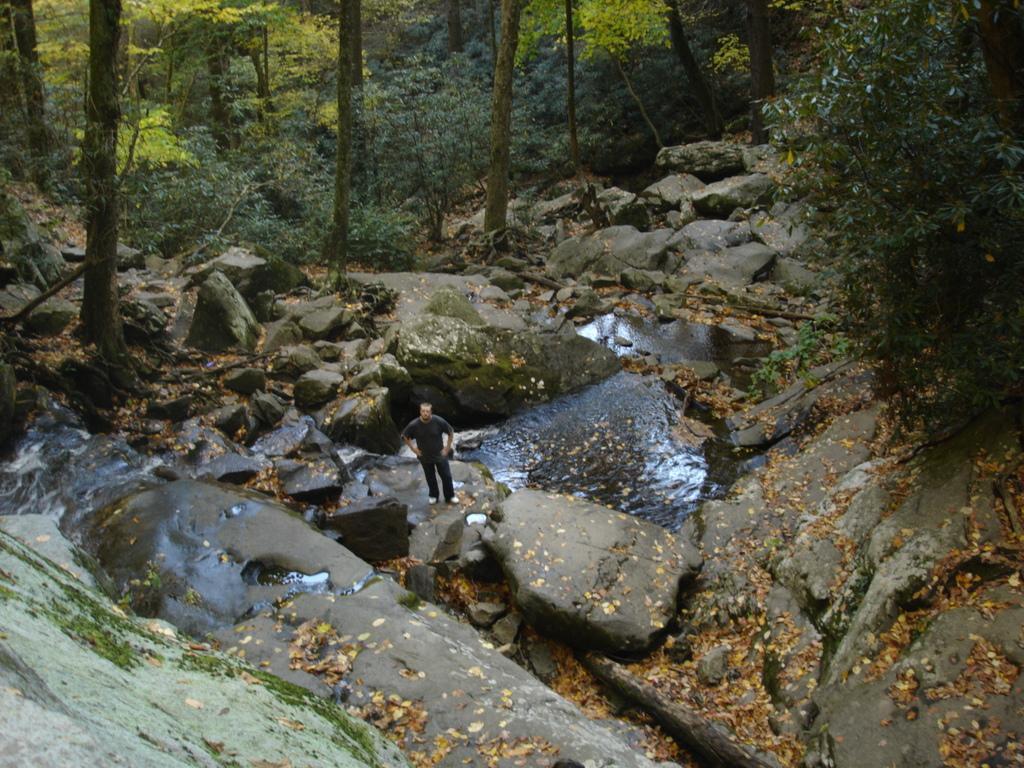Please provide a concise description of this image. In the foreground of this image, there are rocks, river and on either side to the river, there are trees and a man standing on the rock. 